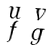<formula> <loc_0><loc_0><loc_500><loc_500>\begin{smallmatrix} u & v \\ f & g \end{smallmatrix}</formula> 